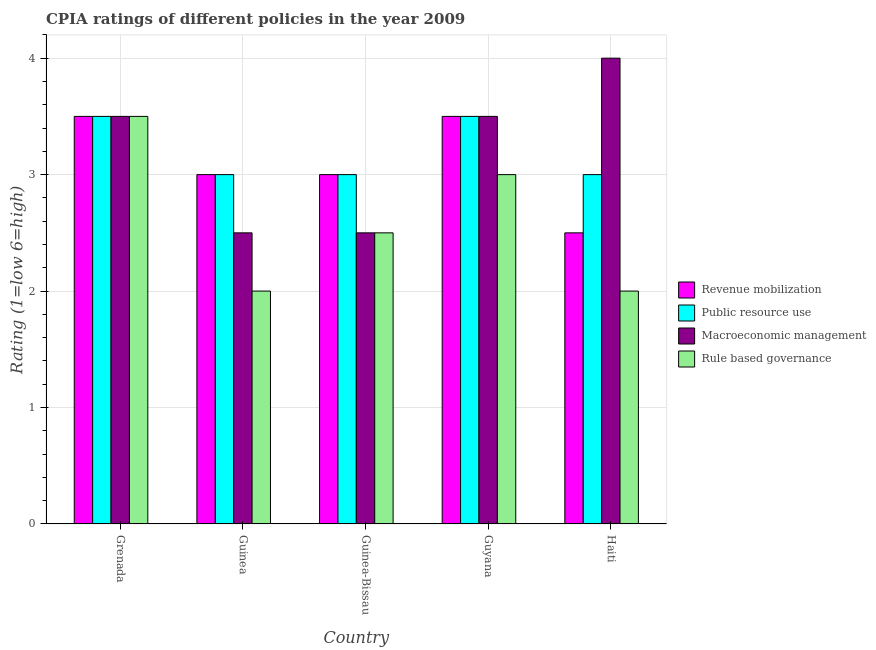How many different coloured bars are there?
Ensure brevity in your answer.  4. How many groups of bars are there?
Your answer should be compact. 5. Are the number of bars per tick equal to the number of legend labels?
Your answer should be very brief. Yes. How many bars are there on the 5th tick from the right?
Offer a very short reply. 4. What is the label of the 4th group of bars from the left?
Your answer should be compact. Guyana. In which country was the cpia rating of macroeconomic management maximum?
Make the answer very short. Haiti. In which country was the cpia rating of public resource use minimum?
Make the answer very short. Guinea. What is the difference between the cpia rating of macroeconomic management in Grenada and that in Guinea-Bissau?
Your answer should be compact. 1. What is the average cpia rating of macroeconomic management per country?
Your response must be concise. 3.2. In how many countries, is the cpia rating of public resource use greater than 0.4 ?
Your answer should be very brief. 5. Is the cpia rating of macroeconomic management in Guinea-Bissau less than that in Guyana?
Offer a very short reply. Yes. What is the difference between the highest and the second highest cpia rating of rule based governance?
Keep it short and to the point. 0.5. What is the difference between the highest and the lowest cpia rating of rule based governance?
Ensure brevity in your answer.  1.5. In how many countries, is the cpia rating of revenue mobilization greater than the average cpia rating of revenue mobilization taken over all countries?
Your answer should be very brief. 2. Is the sum of the cpia rating of rule based governance in Grenada and Haiti greater than the maximum cpia rating of macroeconomic management across all countries?
Give a very brief answer. Yes. What does the 4th bar from the left in Guinea represents?
Your answer should be compact. Rule based governance. What does the 2nd bar from the right in Guinea represents?
Your response must be concise. Macroeconomic management. Is it the case that in every country, the sum of the cpia rating of revenue mobilization and cpia rating of public resource use is greater than the cpia rating of macroeconomic management?
Your answer should be compact. Yes. How many bars are there?
Offer a very short reply. 20. Are all the bars in the graph horizontal?
Give a very brief answer. No. What is the difference between two consecutive major ticks on the Y-axis?
Your response must be concise. 1. Does the graph contain grids?
Your answer should be compact. Yes. Where does the legend appear in the graph?
Offer a very short reply. Center right. How many legend labels are there?
Ensure brevity in your answer.  4. How are the legend labels stacked?
Offer a very short reply. Vertical. What is the title of the graph?
Your answer should be compact. CPIA ratings of different policies in the year 2009. Does "Methodology assessment" appear as one of the legend labels in the graph?
Your response must be concise. No. What is the label or title of the X-axis?
Your answer should be very brief. Country. What is the Rating (1=low 6=high) of Revenue mobilization in Grenada?
Give a very brief answer. 3.5. What is the Rating (1=low 6=high) of Public resource use in Grenada?
Offer a very short reply. 3.5. What is the Rating (1=low 6=high) in Revenue mobilization in Guinea-Bissau?
Your answer should be very brief. 3. What is the Rating (1=low 6=high) of Public resource use in Guinea-Bissau?
Offer a very short reply. 3. What is the Rating (1=low 6=high) of Rule based governance in Guinea-Bissau?
Your answer should be compact. 2.5. What is the Rating (1=low 6=high) of Revenue mobilization in Guyana?
Provide a succinct answer. 3.5. What is the Rating (1=low 6=high) of Public resource use in Guyana?
Your response must be concise. 3.5. What is the Rating (1=low 6=high) of Macroeconomic management in Guyana?
Give a very brief answer. 3.5. What is the Rating (1=low 6=high) of Rule based governance in Guyana?
Provide a succinct answer. 3. What is the Rating (1=low 6=high) in Macroeconomic management in Haiti?
Your answer should be compact. 4. What is the Rating (1=low 6=high) of Rule based governance in Haiti?
Provide a succinct answer. 2. Across all countries, what is the maximum Rating (1=low 6=high) of Revenue mobilization?
Your response must be concise. 3.5. Across all countries, what is the maximum Rating (1=low 6=high) in Rule based governance?
Offer a terse response. 3.5. Across all countries, what is the minimum Rating (1=low 6=high) in Macroeconomic management?
Your answer should be compact. 2.5. What is the total Rating (1=low 6=high) in Revenue mobilization in the graph?
Offer a very short reply. 15.5. What is the difference between the Rating (1=low 6=high) of Revenue mobilization in Grenada and that in Guinea-Bissau?
Offer a terse response. 0.5. What is the difference between the Rating (1=low 6=high) of Public resource use in Grenada and that in Guinea-Bissau?
Keep it short and to the point. 0.5. What is the difference between the Rating (1=low 6=high) in Macroeconomic management in Grenada and that in Guinea-Bissau?
Offer a terse response. 1. What is the difference between the Rating (1=low 6=high) of Revenue mobilization in Grenada and that in Guyana?
Make the answer very short. 0. What is the difference between the Rating (1=low 6=high) of Public resource use in Grenada and that in Guyana?
Give a very brief answer. 0. What is the difference between the Rating (1=low 6=high) in Public resource use in Grenada and that in Haiti?
Keep it short and to the point. 0.5. What is the difference between the Rating (1=low 6=high) of Public resource use in Guinea and that in Guinea-Bissau?
Provide a short and direct response. 0. What is the difference between the Rating (1=low 6=high) of Macroeconomic management in Guinea and that in Guinea-Bissau?
Offer a very short reply. 0. What is the difference between the Rating (1=low 6=high) in Public resource use in Guinea and that in Guyana?
Ensure brevity in your answer.  -0.5. What is the difference between the Rating (1=low 6=high) of Rule based governance in Guinea and that in Guyana?
Your answer should be very brief. -1. What is the difference between the Rating (1=low 6=high) of Rule based governance in Guinea and that in Haiti?
Keep it short and to the point. 0. What is the difference between the Rating (1=low 6=high) of Public resource use in Guinea-Bissau and that in Guyana?
Ensure brevity in your answer.  -0.5. What is the difference between the Rating (1=low 6=high) in Macroeconomic management in Guinea-Bissau and that in Guyana?
Keep it short and to the point. -1. What is the difference between the Rating (1=low 6=high) in Macroeconomic management in Guinea-Bissau and that in Haiti?
Give a very brief answer. -1.5. What is the difference between the Rating (1=low 6=high) of Revenue mobilization in Guyana and that in Haiti?
Make the answer very short. 1. What is the difference between the Rating (1=low 6=high) of Public resource use in Guyana and that in Haiti?
Offer a terse response. 0.5. What is the difference between the Rating (1=low 6=high) of Rule based governance in Guyana and that in Haiti?
Ensure brevity in your answer.  1. What is the difference between the Rating (1=low 6=high) in Revenue mobilization in Grenada and the Rating (1=low 6=high) in Public resource use in Guinea?
Offer a very short reply. 0.5. What is the difference between the Rating (1=low 6=high) of Revenue mobilization in Grenada and the Rating (1=low 6=high) of Macroeconomic management in Guinea?
Provide a succinct answer. 1. What is the difference between the Rating (1=low 6=high) of Macroeconomic management in Grenada and the Rating (1=low 6=high) of Rule based governance in Guinea?
Provide a short and direct response. 1.5. What is the difference between the Rating (1=low 6=high) in Revenue mobilization in Grenada and the Rating (1=low 6=high) in Public resource use in Guinea-Bissau?
Your answer should be compact. 0.5. What is the difference between the Rating (1=low 6=high) in Revenue mobilization in Grenada and the Rating (1=low 6=high) in Rule based governance in Guinea-Bissau?
Ensure brevity in your answer.  1. What is the difference between the Rating (1=low 6=high) in Public resource use in Grenada and the Rating (1=low 6=high) in Macroeconomic management in Guyana?
Ensure brevity in your answer.  0. What is the difference between the Rating (1=low 6=high) of Revenue mobilization in Grenada and the Rating (1=low 6=high) of Public resource use in Haiti?
Offer a terse response. 0.5. What is the difference between the Rating (1=low 6=high) in Revenue mobilization in Grenada and the Rating (1=low 6=high) in Macroeconomic management in Haiti?
Your answer should be very brief. -0.5. What is the difference between the Rating (1=low 6=high) in Revenue mobilization in Grenada and the Rating (1=low 6=high) in Rule based governance in Haiti?
Your response must be concise. 1.5. What is the difference between the Rating (1=low 6=high) in Public resource use in Grenada and the Rating (1=low 6=high) in Rule based governance in Haiti?
Make the answer very short. 1.5. What is the difference between the Rating (1=low 6=high) in Macroeconomic management in Grenada and the Rating (1=low 6=high) in Rule based governance in Haiti?
Your answer should be compact. 1.5. What is the difference between the Rating (1=low 6=high) in Revenue mobilization in Guinea and the Rating (1=low 6=high) in Rule based governance in Guinea-Bissau?
Your response must be concise. 0.5. What is the difference between the Rating (1=low 6=high) of Revenue mobilization in Guinea and the Rating (1=low 6=high) of Rule based governance in Guyana?
Ensure brevity in your answer.  0. What is the difference between the Rating (1=low 6=high) of Public resource use in Guinea and the Rating (1=low 6=high) of Rule based governance in Guyana?
Make the answer very short. 0. What is the difference between the Rating (1=low 6=high) of Macroeconomic management in Guinea and the Rating (1=low 6=high) of Rule based governance in Guyana?
Your response must be concise. -0.5. What is the difference between the Rating (1=low 6=high) of Revenue mobilization in Guinea-Bissau and the Rating (1=low 6=high) of Rule based governance in Guyana?
Provide a succinct answer. 0. What is the difference between the Rating (1=low 6=high) in Public resource use in Guinea-Bissau and the Rating (1=low 6=high) in Rule based governance in Guyana?
Provide a succinct answer. 0. What is the difference between the Rating (1=low 6=high) in Macroeconomic management in Guinea-Bissau and the Rating (1=low 6=high) in Rule based governance in Guyana?
Make the answer very short. -0.5. What is the difference between the Rating (1=low 6=high) in Revenue mobilization in Guinea-Bissau and the Rating (1=low 6=high) in Macroeconomic management in Haiti?
Keep it short and to the point. -1. What is the difference between the Rating (1=low 6=high) in Revenue mobilization in Guinea-Bissau and the Rating (1=low 6=high) in Rule based governance in Haiti?
Ensure brevity in your answer.  1. What is the difference between the Rating (1=low 6=high) in Public resource use in Guinea-Bissau and the Rating (1=low 6=high) in Macroeconomic management in Haiti?
Provide a succinct answer. -1. What is the difference between the Rating (1=low 6=high) of Public resource use in Guinea-Bissau and the Rating (1=low 6=high) of Rule based governance in Haiti?
Your answer should be compact. 1. What is the difference between the Rating (1=low 6=high) of Revenue mobilization in Guyana and the Rating (1=low 6=high) of Macroeconomic management in Haiti?
Provide a succinct answer. -0.5. What is the difference between the Rating (1=low 6=high) of Revenue mobilization in Guyana and the Rating (1=low 6=high) of Rule based governance in Haiti?
Provide a succinct answer. 1.5. What is the difference between the Rating (1=low 6=high) of Macroeconomic management in Guyana and the Rating (1=low 6=high) of Rule based governance in Haiti?
Make the answer very short. 1.5. What is the average Rating (1=low 6=high) of Macroeconomic management per country?
Your answer should be compact. 3.2. What is the difference between the Rating (1=low 6=high) in Revenue mobilization and Rating (1=low 6=high) in Public resource use in Grenada?
Offer a very short reply. 0. What is the difference between the Rating (1=low 6=high) in Revenue mobilization and Rating (1=low 6=high) in Macroeconomic management in Grenada?
Offer a terse response. 0. What is the difference between the Rating (1=low 6=high) of Macroeconomic management and Rating (1=low 6=high) of Rule based governance in Grenada?
Your answer should be very brief. 0. What is the difference between the Rating (1=low 6=high) in Revenue mobilization and Rating (1=low 6=high) in Public resource use in Guinea?
Offer a very short reply. 0. What is the difference between the Rating (1=low 6=high) in Revenue mobilization and Rating (1=low 6=high) in Rule based governance in Guinea?
Keep it short and to the point. 1. What is the difference between the Rating (1=low 6=high) in Public resource use and Rating (1=low 6=high) in Macroeconomic management in Guinea?
Your answer should be very brief. 0.5. What is the difference between the Rating (1=low 6=high) in Public resource use and Rating (1=low 6=high) in Rule based governance in Guinea?
Ensure brevity in your answer.  1. What is the difference between the Rating (1=low 6=high) of Public resource use and Rating (1=low 6=high) of Macroeconomic management in Guinea-Bissau?
Ensure brevity in your answer.  0.5. What is the difference between the Rating (1=low 6=high) in Revenue mobilization and Rating (1=low 6=high) in Rule based governance in Guyana?
Provide a short and direct response. 0.5. What is the difference between the Rating (1=low 6=high) of Public resource use and Rating (1=low 6=high) of Macroeconomic management in Guyana?
Keep it short and to the point. 0. What is the difference between the Rating (1=low 6=high) of Public resource use and Rating (1=low 6=high) of Rule based governance in Guyana?
Your response must be concise. 0.5. What is the difference between the Rating (1=low 6=high) in Macroeconomic management and Rating (1=low 6=high) in Rule based governance in Guyana?
Make the answer very short. 0.5. What is the difference between the Rating (1=low 6=high) in Revenue mobilization and Rating (1=low 6=high) in Public resource use in Haiti?
Keep it short and to the point. -0.5. What is the difference between the Rating (1=low 6=high) of Revenue mobilization and Rating (1=low 6=high) of Rule based governance in Haiti?
Keep it short and to the point. 0.5. What is the difference between the Rating (1=low 6=high) in Macroeconomic management and Rating (1=low 6=high) in Rule based governance in Haiti?
Your answer should be compact. 2. What is the ratio of the Rating (1=low 6=high) in Revenue mobilization in Grenada to that in Guinea?
Provide a short and direct response. 1.17. What is the ratio of the Rating (1=low 6=high) in Public resource use in Grenada to that in Guinea?
Keep it short and to the point. 1.17. What is the ratio of the Rating (1=low 6=high) in Macroeconomic management in Grenada to that in Guinea-Bissau?
Make the answer very short. 1.4. What is the ratio of the Rating (1=low 6=high) in Rule based governance in Grenada to that in Guinea-Bissau?
Offer a terse response. 1.4. What is the ratio of the Rating (1=low 6=high) of Revenue mobilization in Grenada to that in Guyana?
Provide a short and direct response. 1. What is the ratio of the Rating (1=low 6=high) of Macroeconomic management in Grenada to that in Guyana?
Your response must be concise. 1. What is the ratio of the Rating (1=low 6=high) in Rule based governance in Grenada to that in Guyana?
Provide a succinct answer. 1.17. What is the ratio of the Rating (1=low 6=high) in Revenue mobilization in Grenada to that in Haiti?
Offer a terse response. 1.4. What is the ratio of the Rating (1=low 6=high) in Public resource use in Grenada to that in Haiti?
Your response must be concise. 1.17. What is the ratio of the Rating (1=low 6=high) in Rule based governance in Grenada to that in Haiti?
Offer a terse response. 1.75. What is the ratio of the Rating (1=low 6=high) in Revenue mobilization in Guinea to that in Guinea-Bissau?
Your answer should be compact. 1. What is the ratio of the Rating (1=low 6=high) in Public resource use in Guinea to that in Guinea-Bissau?
Provide a short and direct response. 1. What is the ratio of the Rating (1=low 6=high) in Public resource use in Guinea to that in Guyana?
Offer a very short reply. 0.86. What is the ratio of the Rating (1=low 6=high) in Macroeconomic management in Guinea to that in Guyana?
Offer a very short reply. 0.71. What is the ratio of the Rating (1=low 6=high) in Rule based governance in Guinea to that in Guyana?
Offer a terse response. 0.67. What is the ratio of the Rating (1=low 6=high) of Revenue mobilization in Guinea to that in Haiti?
Your answer should be very brief. 1.2. What is the ratio of the Rating (1=low 6=high) of Rule based governance in Guinea to that in Haiti?
Your response must be concise. 1. What is the ratio of the Rating (1=low 6=high) of Revenue mobilization in Guinea-Bissau to that in Guyana?
Provide a succinct answer. 0.86. What is the ratio of the Rating (1=low 6=high) in Public resource use in Guinea-Bissau to that in Guyana?
Your answer should be very brief. 0.86. What is the ratio of the Rating (1=low 6=high) of Macroeconomic management in Guinea-Bissau to that in Guyana?
Provide a succinct answer. 0.71. What is the ratio of the Rating (1=low 6=high) of Revenue mobilization in Guinea-Bissau to that in Haiti?
Make the answer very short. 1.2. What is the ratio of the Rating (1=low 6=high) in Revenue mobilization in Guyana to that in Haiti?
Ensure brevity in your answer.  1.4. What is the ratio of the Rating (1=low 6=high) of Rule based governance in Guyana to that in Haiti?
Make the answer very short. 1.5. What is the difference between the highest and the second highest Rating (1=low 6=high) of Rule based governance?
Offer a very short reply. 0.5. What is the difference between the highest and the lowest Rating (1=low 6=high) in Revenue mobilization?
Your answer should be compact. 1. What is the difference between the highest and the lowest Rating (1=low 6=high) of Public resource use?
Give a very brief answer. 0.5. What is the difference between the highest and the lowest Rating (1=low 6=high) in Macroeconomic management?
Your answer should be very brief. 1.5. 